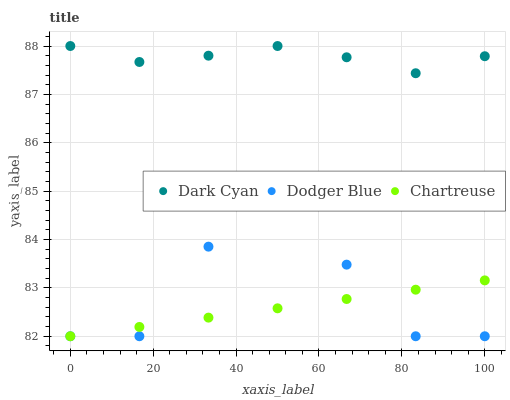Does Chartreuse have the minimum area under the curve?
Answer yes or no. Yes. Does Dark Cyan have the maximum area under the curve?
Answer yes or no. Yes. Does Dodger Blue have the minimum area under the curve?
Answer yes or no. No. Does Dodger Blue have the maximum area under the curve?
Answer yes or no. No. Is Chartreuse the smoothest?
Answer yes or no. Yes. Is Dodger Blue the roughest?
Answer yes or no. Yes. Is Dodger Blue the smoothest?
Answer yes or no. No. Is Chartreuse the roughest?
Answer yes or no. No. Does Chartreuse have the lowest value?
Answer yes or no. Yes. Does Dark Cyan have the highest value?
Answer yes or no. Yes. Does Dodger Blue have the highest value?
Answer yes or no. No. Is Chartreuse less than Dark Cyan?
Answer yes or no. Yes. Is Dark Cyan greater than Dodger Blue?
Answer yes or no. Yes. Does Dodger Blue intersect Chartreuse?
Answer yes or no. Yes. Is Dodger Blue less than Chartreuse?
Answer yes or no. No. Is Dodger Blue greater than Chartreuse?
Answer yes or no. No. Does Chartreuse intersect Dark Cyan?
Answer yes or no. No. 